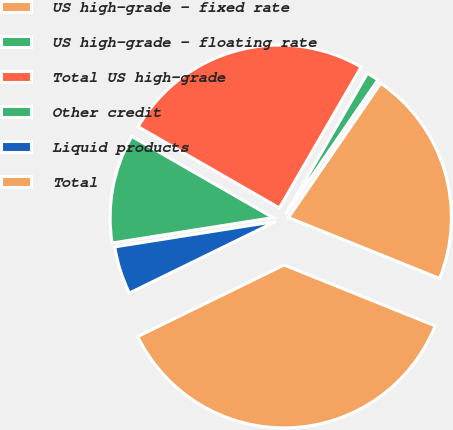Convert chart to OTSL. <chart><loc_0><loc_0><loc_500><loc_500><pie_chart><fcel>US high-grade - fixed rate<fcel>US high-grade - floating rate<fcel>Total US high-grade<fcel>Other credit<fcel>Liquid products<fcel>Total<nl><fcel>21.52%<fcel>1.21%<fcel>25.06%<fcel>10.8%<fcel>4.75%<fcel>36.66%<nl></chart> 